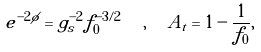<formula> <loc_0><loc_0><loc_500><loc_500>e ^ { - 2 \phi } = g _ { s } ^ { - 2 } f _ { 0 } ^ { - 3 / 2 } \ \ , \ \ A _ { t } = 1 - \frac { 1 } { f _ { 0 } } ,</formula> 